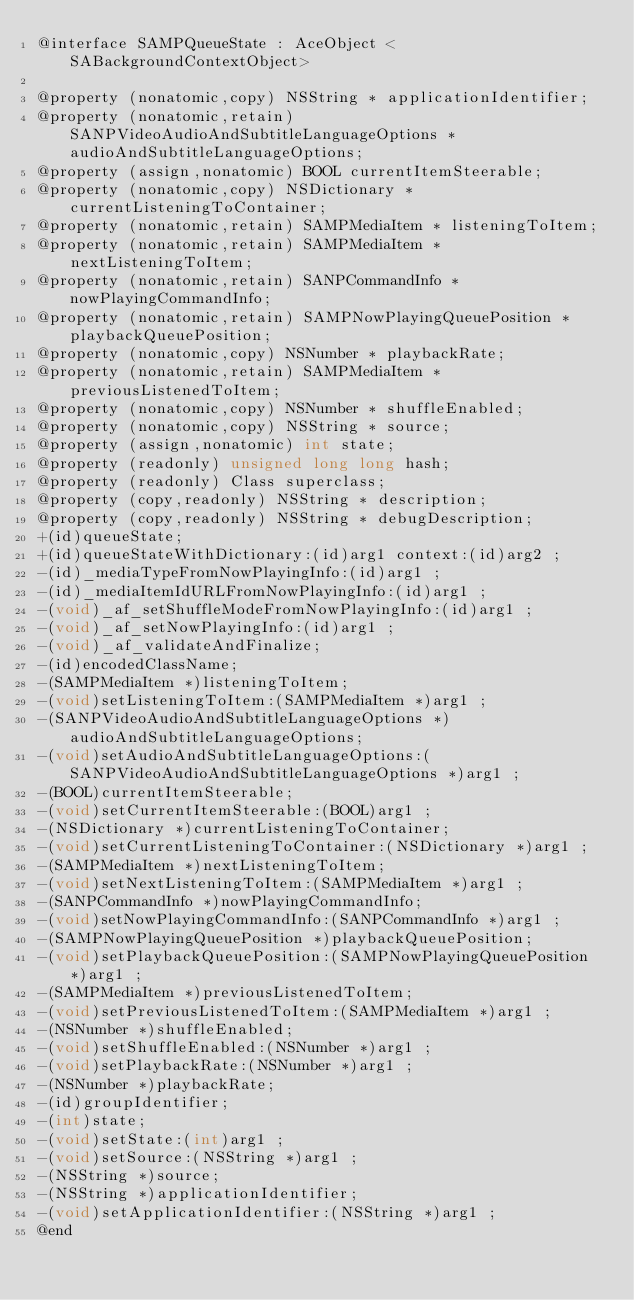<code> <loc_0><loc_0><loc_500><loc_500><_C_>@interface SAMPQueueState : AceObject <SABackgroundContextObject>

@property (nonatomic,copy) NSString * applicationIdentifier; 
@property (nonatomic,retain) SANPVideoAudioAndSubtitleLanguageOptions * audioAndSubtitleLanguageOptions; 
@property (assign,nonatomic) BOOL currentItemSteerable; 
@property (nonatomic,copy) NSDictionary * currentListeningToContainer; 
@property (nonatomic,retain) SAMPMediaItem * listeningToItem; 
@property (nonatomic,retain) SAMPMediaItem * nextListeningToItem; 
@property (nonatomic,retain) SANPCommandInfo * nowPlayingCommandInfo; 
@property (nonatomic,retain) SAMPNowPlayingQueuePosition * playbackQueuePosition; 
@property (nonatomic,copy) NSNumber * playbackRate; 
@property (nonatomic,retain) SAMPMediaItem * previousListenedToItem; 
@property (nonatomic,copy) NSNumber * shuffleEnabled; 
@property (nonatomic,copy) NSString * source; 
@property (assign,nonatomic) int state; 
@property (readonly) unsigned long long hash; 
@property (readonly) Class superclass; 
@property (copy,readonly) NSString * description; 
@property (copy,readonly) NSString * debugDescription; 
+(id)queueState;
+(id)queueStateWithDictionary:(id)arg1 context:(id)arg2 ;
-(id)_mediaTypeFromNowPlayingInfo:(id)arg1 ;
-(id)_mediaItemIdURLFromNowPlayingInfo:(id)arg1 ;
-(void)_af_setShuffleModeFromNowPlayingInfo:(id)arg1 ;
-(void)_af_setNowPlayingInfo:(id)arg1 ;
-(void)_af_validateAndFinalize;
-(id)encodedClassName;
-(SAMPMediaItem *)listeningToItem;
-(void)setListeningToItem:(SAMPMediaItem *)arg1 ;
-(SANPVideoAudioAndSubtitleLanguageOptions *)audioAndSubtitleLanguageOptions;
-(void)setAudioAndSubtitleLanguageOptions:(SANPVideoAudioAndSubtitleLanguageOptions *)arg1 ;
-(BOOL)currentItemSteerable;
-(void)setCurrentItemSteerable:(BOOL)arg1 ;
-(NSDictionary *)currentListeningToContainer;
-(void)setCurrentListeningToContainer:(NSDictionary *)arg1 ;
-(SAMPMediaItem *)nextListeningToItem;
-(void)setNextListeningToItem:(SAMPMediaItem *)arg1 ;
-(SANPCommandInfo *)nowPlayingCommandInfo;
-(void)setNowPlayingCommandInfo:(SANPCommandInfo *)arg1 ;
-(SAMPNowPlayingQueuePosition *)playbackQueuePosition;
-(void)setPlaybackQueuePosition:(SAMPNowPlayingQueuePosition *)arg1 ;
-(SAMPMediaItem *)previousListenedToItem;
-(void)setPreviousListenedToItem:(SAMPMediaItem *)arg1 ;
-(NSNumber *)shuffleEnabled;
-(void)setShuffleEnabled:(NSNumber *)arg1 ;
-(void)setPlaybackRate:(NSNumber *)arg1 ;
-(NSNumber *)playbackRate;
-(id)groupIdentifier;
-(int)state;
-(void)setState:(int)arg1 ;
-(void)setSource:(NSString *)arg1 ;
-(NSString *)source;
-(NSString *)applicationIdentifier;
-(void)setApplicationIdentifier:(NSString *)arg1 ;
@end

</code> 